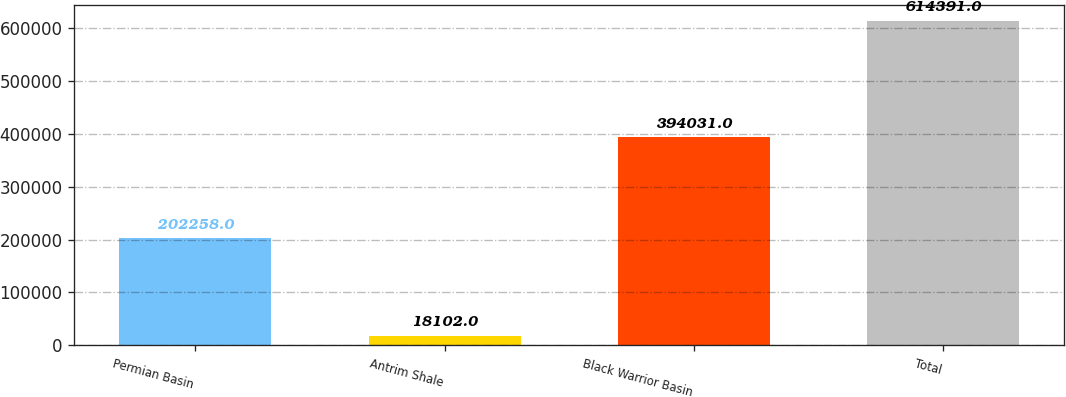Convert chart. <chart><loc_0><loc_0><loc_500><loc_500><bar_chart><fcel>Permian Basin<fcel>Antrim Shale<fcel>Black Warrior Basin<fcel>Total<nl><fcel>202258<fcel>18102<fcel>394031<fcel>614391<nl></chart> 